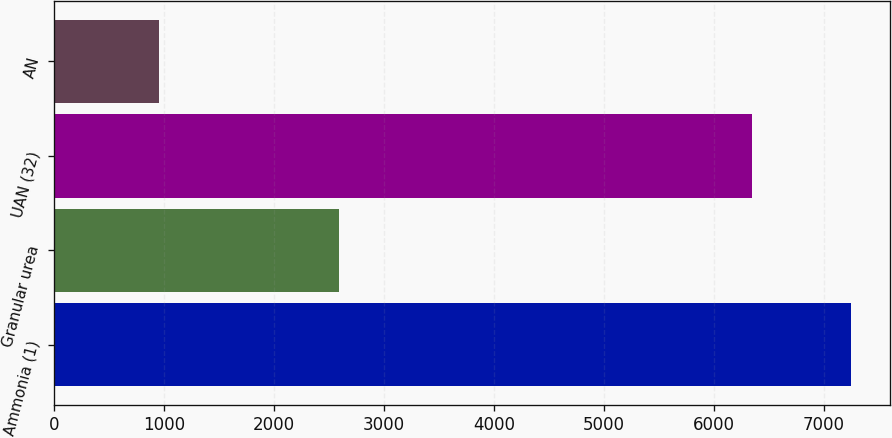Convert chart. <chart><loc_0><loc_0><loc_500><loc_500><bar_chart><fcel>Ammonia (1)<fcel>Granular urea<fcel>UAN (32)<fcel>AN<nl><fcel>7244<fcel>2588<fcel>6349<fcel>952<nl></chart> 